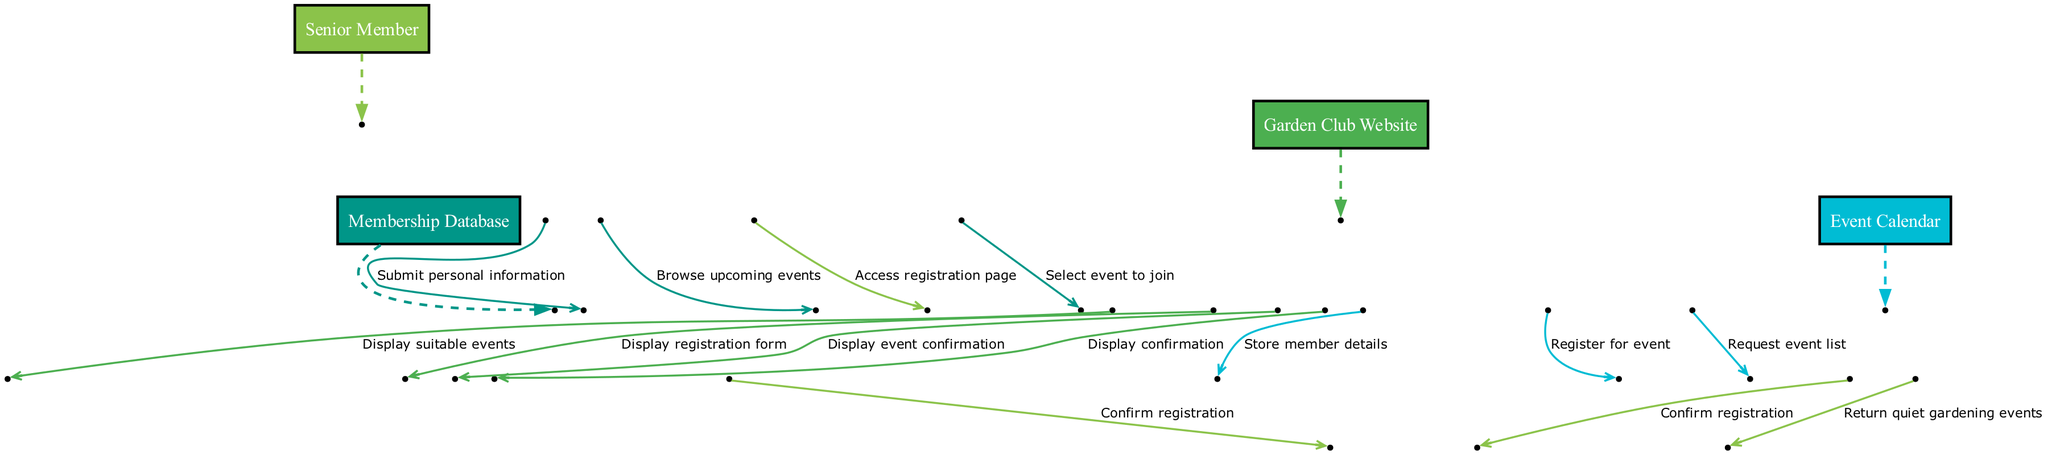What is the first action taken by the Senior Member? The first action is "Access registration page," where the Senior Member initiates the process of joining the Garden Club by visiting the website's registration page.
Answer: Access registration page How many actors are involved in the sequence diagram? There are four actors: "Senior Member," "Garden Club Website," "Membership Database," and "Event Calendar." Each actor plays a role in the sequence of events.
Answer: Four What message does the Garden Club Website send to the Membership Database? The message is "Store member details," which indicates that once the Senior Member submits their information, the website relays this information to the Membership Database for storage.
Answer: Store member details Which actor is responsible for displaying the confirmation of registration? The "Garden Club Website" is responsible for displaying the confirmation of registration to the Senior Member after the registration process is completed.
Answer: Garden Club Website What action does the Senior Member take to find suitable events? The action taken is "Browse upcoming events," where the Senior Member looks for events that might be of interest after confirming their membership.
Answer: Browse upcoming events How many messages are exchanged between the Garden Club Website and the Event Calendar? There are three messages exchanged: "Request event list," "Return quiet gardening events," and "Register for event." These messages facilitate the interaction related to event participation.
Answer: Three What is the last message displayed to the Senior Member? The last message displayed is "Display event confirmation," which indicates that the Senior Member receives confirmation after successfully registering for an event.
Answer: Display event confirmation What type of events does the Event Calendar return to the Garden Club Website? The Event Calendar returns "quiet gardening events," which highlights the preference for peaceful activities in line with the Senior Member's taste.
Answer: Quiet gardening events What does the Senior Member submit to the Garden Club Website? The Senior Member submits "personal information," which is necessary for completing the registration process to become a member of the club.
Answer: Personal information 